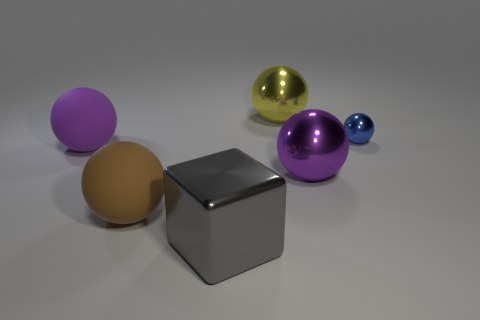Add 1 tiny cyan matte spheres. How many objects exist? 7 Subtract all purple rubber balls. How many balls are left? 4 Subtract all brown balls. How many balls are left? 4 Subtract all balls. How many objects are left? 1 Subtract all red cubes. How many purple balls are left? 2 Subtract 1 cubes. How many cubes are left? 0 Subtract all red metallic spheres. Subtract all large gray things. How many objects are left? 5 Add 2 large yellow metal spheres. How many large yellow metal spheres are left? 3 Add 5 big objects. How many big objects exist? 10 Subtract 0 blue cylinders. How many objects are left? 6 